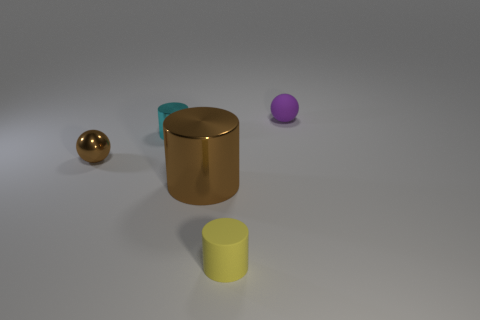There is a tiny thing that is on the right side of the large cylinder and behind the small yellow rubber thing; what is its color?
Offer a very short reply. Purple. Do the sphere that is left of the matte cylinder and the cylinder that is to the left of the big brown shiny cylinder have the same material?
Give a very brief answer. Yes. There is a sphere that is left of the purple matte sphere; is its size the same as the small purple ball?
Give a very brief answer. Yes. Is the color of the tiny matte sphere the same as the small rubber thing that is left of the tiny rubber sphere?
Provide a short and direct response. No. What is the shape of the other thing that is the same color as the large metallic thing?
Provide a short and direct response. Sphere. There is a big brown metal thing; what shape is it?
Ensure brevity in your answer.  Cylinder. Does the matte cylinder have the same color as the rubber sphere?
Provide a succinct answer. No. What number of things are either balls on the left side of the small yellow matte thing or green rubber things?
Your answer should be compact. 1. There is another cyan thing that is the same material as the large thing; what is its size?
Keep it short and to the point. Small. Is the number of small yellow rubber cylinders in front of the large cylinder greater than the number of small cubes?
Offer a very short reply. Yes. 